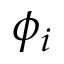<formula> <loc_0><loc_0><loc_500><loc_500>\phi _ { i }</formula> 